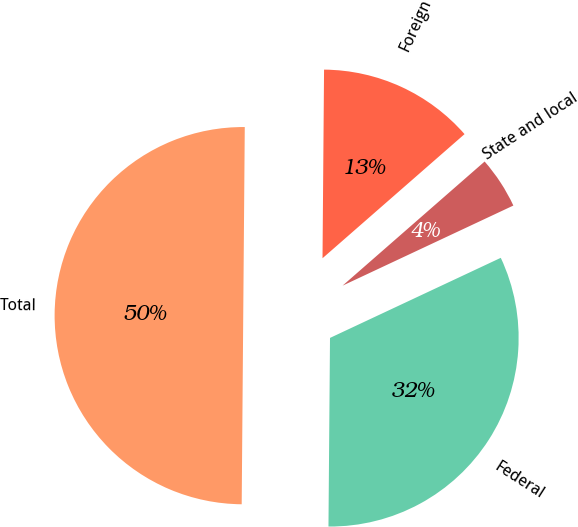Convert chart. <chart><loc_0><loc_0><loc_500><loc_500><pie_chart><fcel>Federal<fcel>State and local<fcel>Foreign<fcel>Total<nl><fcel>32.11%<fcel>4.45%<fcel>13.44%<fcel>50.0%<nl></chart> 